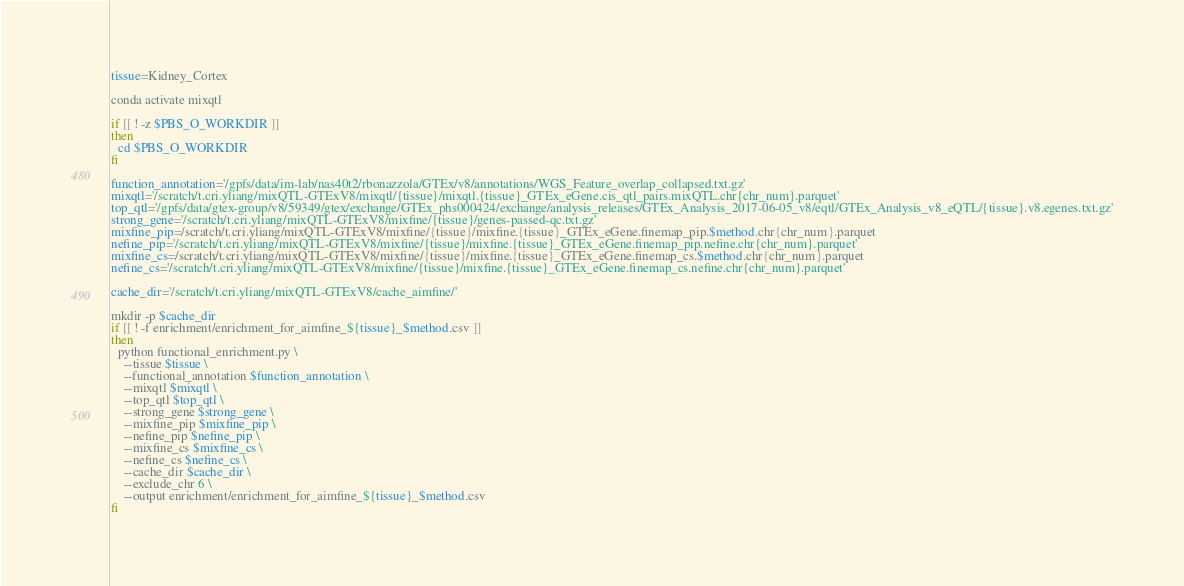Convert code to text. <code><loc_0><loc_0><loc_500><loc_500><_Bash_>
tissue=Kidney_Cortex

conda activate mixqtl

if [[ ! -z $PBS_O_WORKDIR ]]
then
  cd $PBS_O_WORKDIR
fi

function_annotation='/gpfs/data/im-lab/nas40t2/rbonazzola/GTEx/v8/annotations/WGS_Feature_overlap_collapsed.txt.gz'
mixqtl='/scratch/t.cri.yliang/mixQTL-GTExV8/mixqtl/{tissue}/mixqtl.{tissue}_GTEx_eGene.cis_qtl_pairs.mixQTL.chr{chr_num}.parquet'
top_qtl='/gpfs/data/gtex-group/v8/59349/gtex/exchange/GTEx_phs000424/exchange/analysis_releases/GTEx_Analysis_2017-06-05_v8/eqtl/GTEx_Analysis_v8_eQTL/{tissue}.v8.egenes.txt.gz'
strong_gene='/scratch/t.cri.yliang/mixQTL-GTExV8/mixfine/{tissue}/genes-passed-qc.txt.gz'
mixfine_pip=/scratch/t.cri.yliang/mixQTL-GTExV8/mixfine/{tissue}/mixfine.{tissue}_GTEx_eGene.finemap_pip.$method.chr{chr_num}.parquet
nefine_pip='/scratch/t.cri.yliang/mixQTL-GTExV8/mixfine/{tissue}/mixfine.{tissue}_GTEx_eGene.finemap_pip.nefine.chr{chr_num}.parquet'
mixfine_cs=/scratch/t.cri.yliang/mixQTL-GTExV8/mixfine/{tissue}/mixfine.{tissue}_GTEx_eGene.finemap_cs.$method.chr{chr_num}.parquet
nefine_cs='/scratch/t.cri.yliang/mixQTL-GTExV8/mixfine/{tissue}/mixfine.{tissue}_GTEx_eGene.finemap_cs.nefine.chr{chr_num}.parquet'

cache_dir='/scratch/t.cri.yliang/mixQTL-GTExV8/cache_aimfine/'

mkdir -p $cache_dir
if [[ ! -f enrichment/enrichment_for_aimfine_${tissue}_$method.csv ]]
then
  python functional_enrichment.py \
    --tissue $tissue \
    --functional_annotation $function_annotation \
    --mixqtl $mixqtl \
    --top_qtl $top_qtl \
    --strong_gene $strong_gene \
    --mixfine_pip $mixfine_pip \
    --nefine_pip $nefine_pip \
    --mixfine_cs $mixfine_cs \
    --nefine_cs $nefine_cs \
    --cache_dir $cache_dir \
    --exclude_chr 6 \
    --output enrichment/enrichment_for_aimfine_${tissue}_$method.csv
fi

</code> 